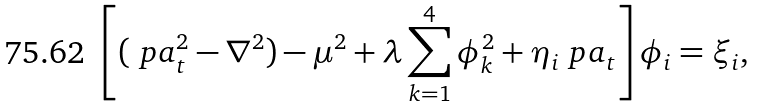<formula> <loc_0><loc_0><loc_500><loc_500>\left [ ( \ p a _ { t } ^ { 2 } - \nabla ^ { 2 } ) - \mu ^ { 2 } + \lambda \sum _ { k = 1 } ^ { 4 } \phi _ { k } ^ { 2 } + \eta _ { i } \ p a _ { t } \right ] \phi _ { i } = \xi _ { i } ,</formula> 